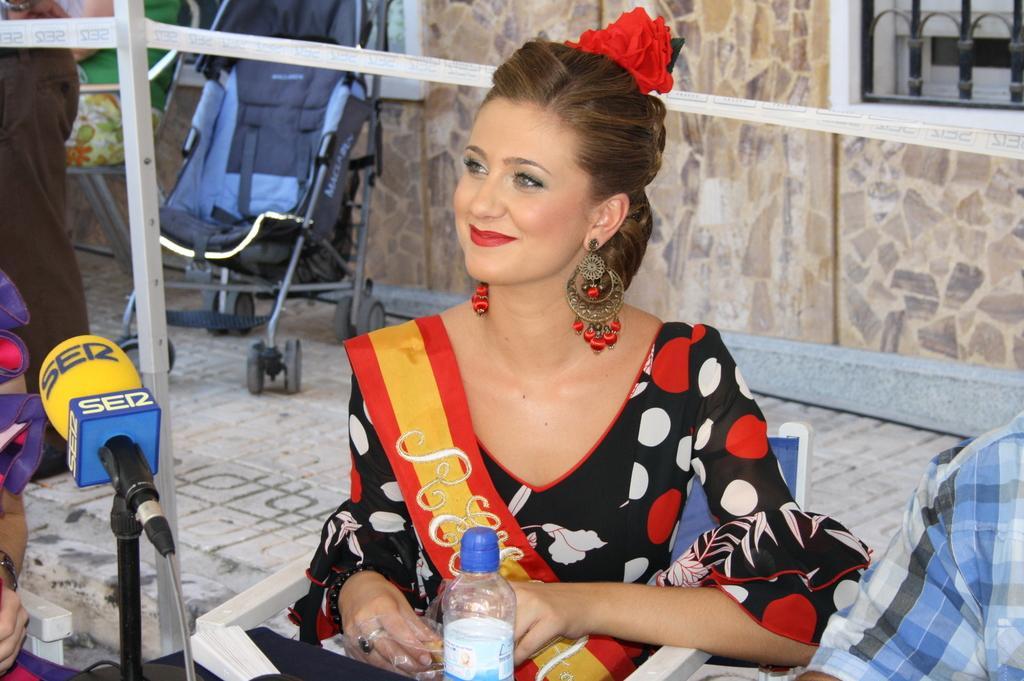Can you describe this image briefly? This person is sitting on a chair. She wore earrings and a black dress. In-front of this woman there is a table, on a table there is a bottle and mic with holder. Beside this woman 2 other persons are sitting on a chair. Far there is a baby chair. 